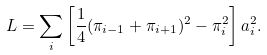Convert formula to latex. <formula><loc_0><loc_0><loc_500><loc_500>L = \sum _ { i } \left [ \frac { 1 } { 4 } ( \pi _ { i - 1 } + \pi _ { i + 1 } ) ^ { 2 } - \pi _ { i } ^ { 2 } \right ] a _ { i } ^ { 2 } .</formula> 